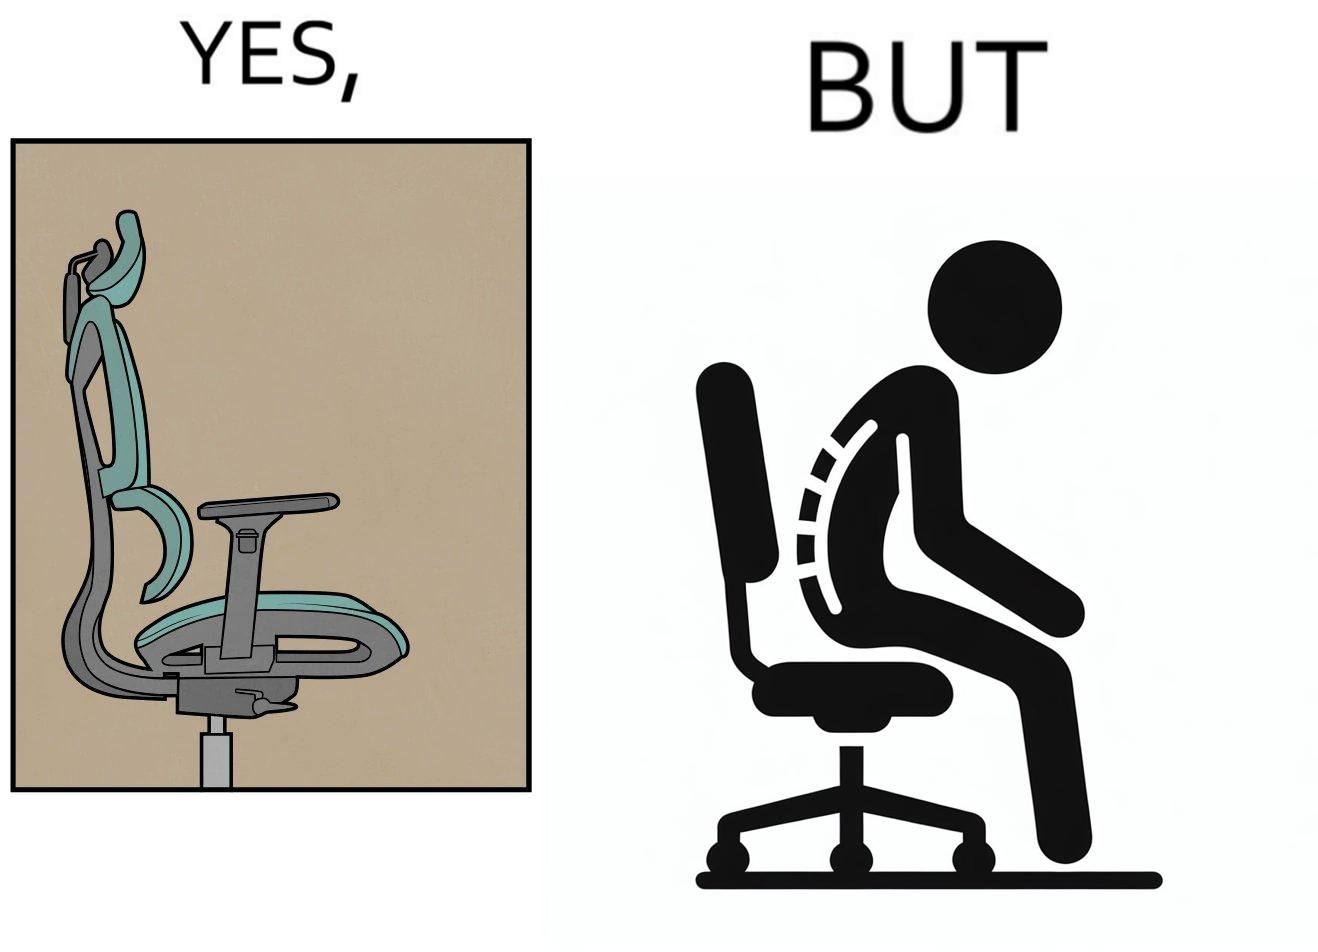Explain why this image is satirical. The image is ironical, as even though the ergonomic chair is meant to facilitate an upright and comfortable posture for the person sitting on it, the person sitting on it still has a bent posture, as the person is not utilizing the backrest. 